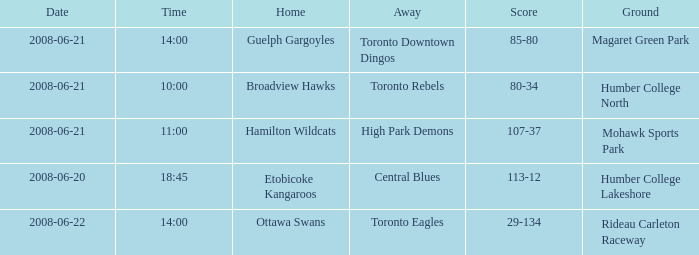What is the Time with a Ground that is humber college north? 10:00. 